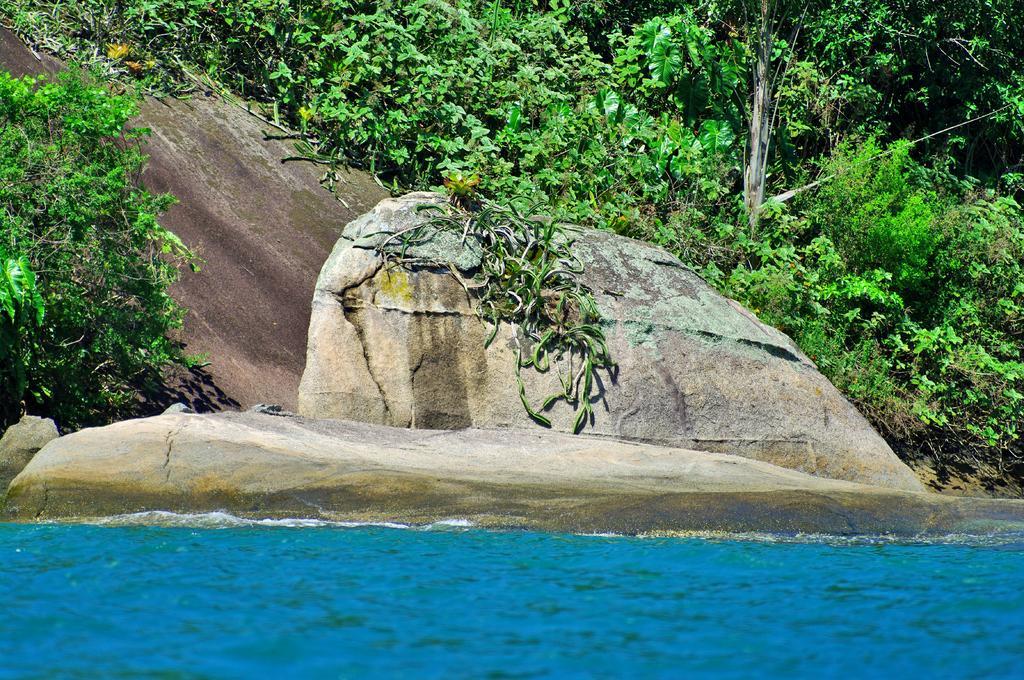In one or two sentences, can you explain what this image depicts? In the image there is a lake in the front and behind it there are huge rocks with plants on either side of it. 